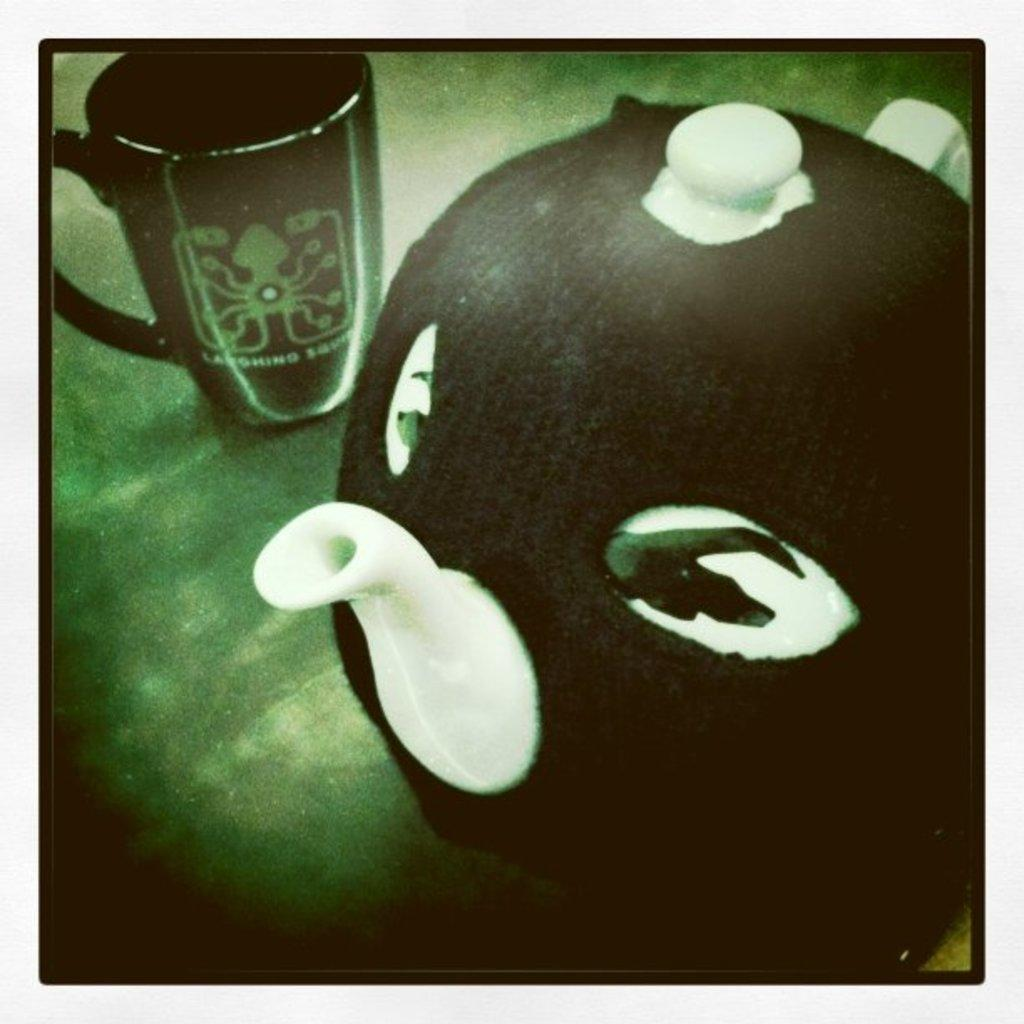What objects are on the ground in the image? There is a jar and a cup on the ground in the image. Can you describe the jar in the image? The jar is one of the objects on the ground in the image. Can you describe the cup in the image? The cup is another object on the ground in the image. What type of skin condition can be seen on the jar in the image? There is no skin condition present on the jar in the image, as it is an inanimate object. What season is depicted in the image? The provided facts do not mention any season or weather conditions, so it cannot be determined from the image. 